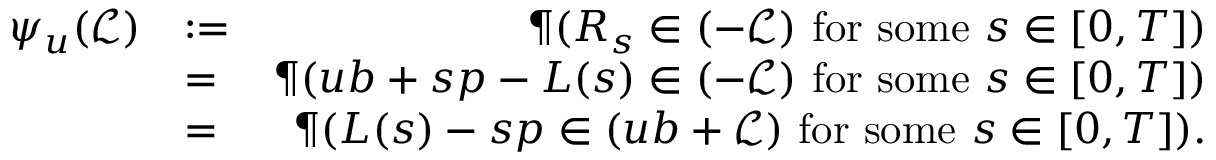<formula> <loc_0><loc_0><loc_500><loc_500>\begin{array} { r l r } { \psi _ { u } ( \mathcal { L } ) } & { \colon = } & { \P ( \boldsymbol R _ { s } \in ( - \mathcal { L } ) f o r s o m e s \in [ 0 , T ] ) } \\ & { = } & { \P ( u \boldsymbol b + s \boldsymbol p - \boldsymbol L ( s ) \in ( - \mathcal { L } ) f o r s o m e s \in [ 0 , T ] ) } \\ & { = } & { \P ( \boldsymbol L ( s ) - s \boldsymbol p \in ( u \boldsymbol b + \mathcal { L } ) f o r s o m e s \in [ 0 , T ] ) . } \end{array}</formula> 